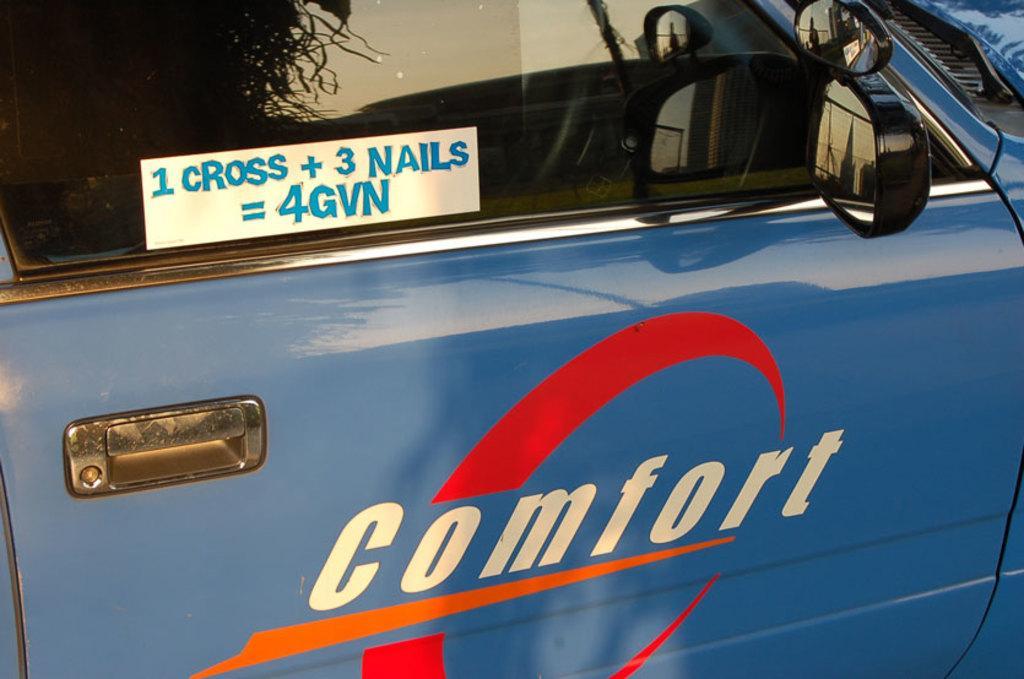Could you give a brief overview of what you see in this image? In this picture we can see a blue color car, on the car there is text. On the right we can see side view mirrors. 